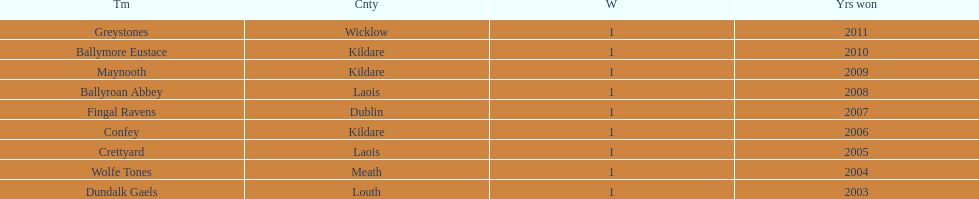What is the ultimate team on the chart? Dundalk Gaels. 